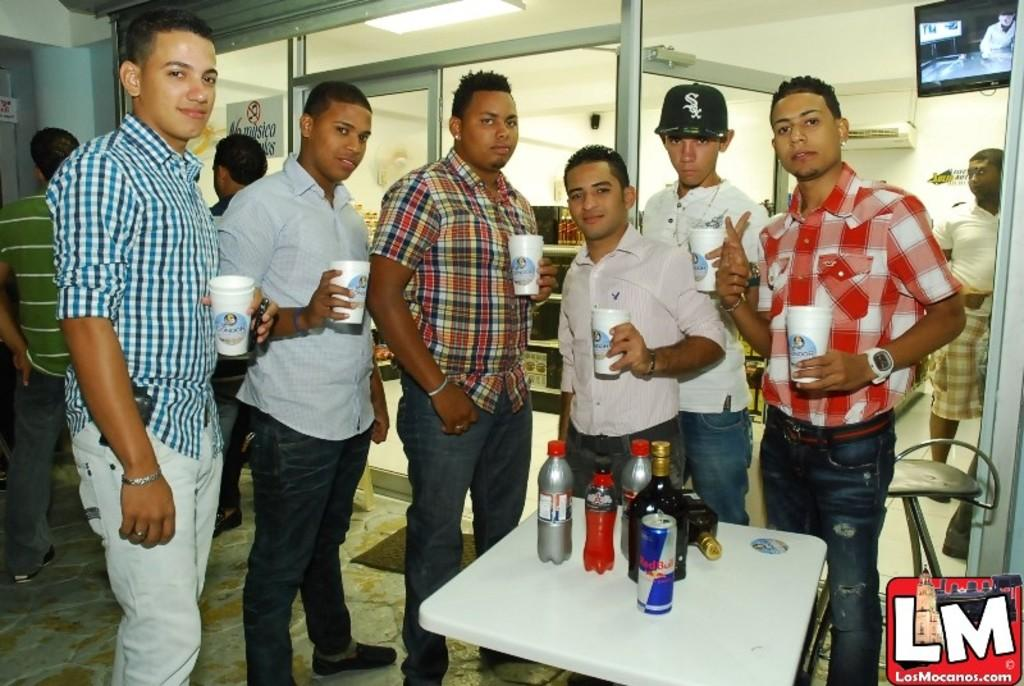How many people are in the image? There is a group of people in the image, but the exact number is not specified. What are the people doing in the image? The people are standing in the image. What are the people holding in their hands? The people are holding a white cup in their hands. What is on the table in front of the group of people? There are drink bottles on the table in front of the group of people. What type of cheese is on the table in the image? There is no cheese present in the image. 